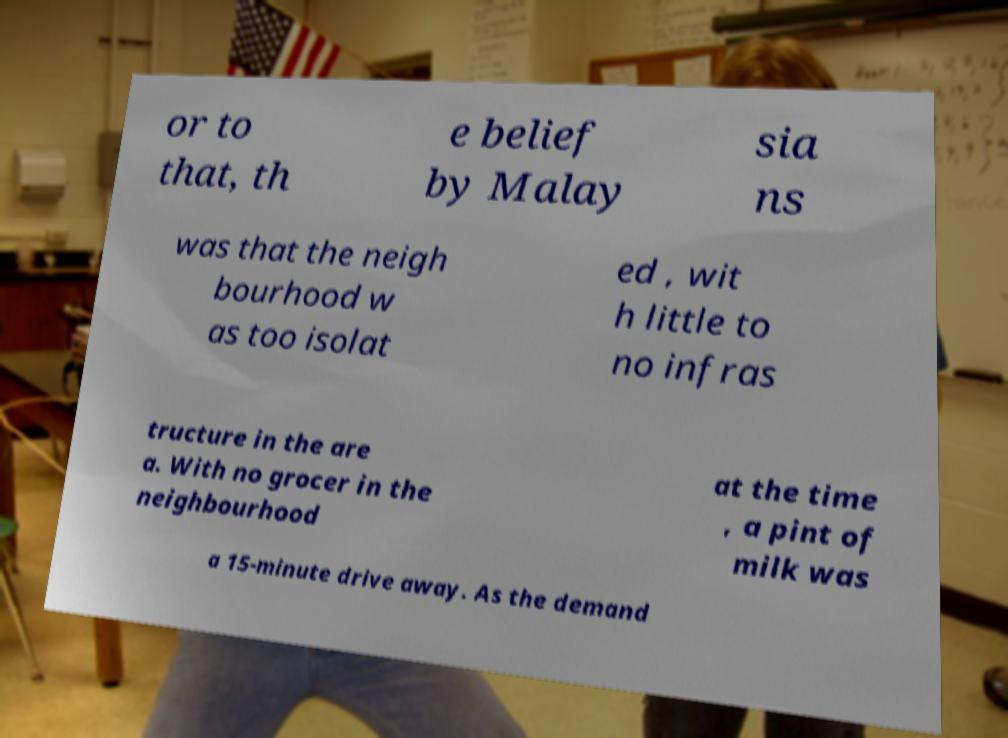Can you read and provide the text displayed in the image?This photo seems to have some interesting text. Can you extract and type it out for me? or to that, th e belief by Malay sia ns was that the neigh bourhood w as too isolat ed , wit h little to no infras tructure in the are a. With no grocer in the neighbourhood at the time , a pint of milk was a 15-minute drive away. As the demand 